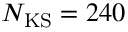Convert formula to latex. <formula><loc_0><loc_0><loc_500><loc_500>N _ { K S } = 2 4 0</formula> 